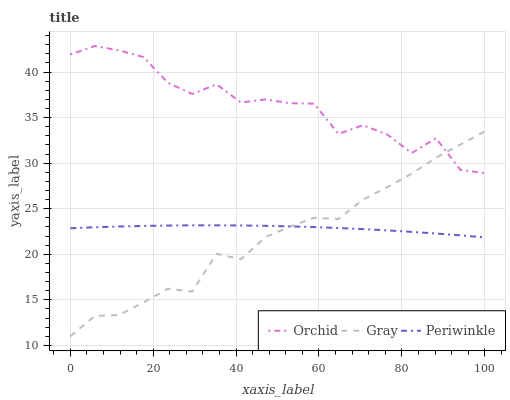Does Gray have the minimum area under the curve?
Answer yes or no. Yes. Does Orchid have the maximum area under the curve?
Answer yes or no. Yes. Does Periwinkle have the minimum area under the curve?
Answer yes or no. No. Does Periwinkle have the maximum area under the curve?
Answer yes or no. No. Is Periwinkle the smoothest?
Answer yes or no. Yes. Is Orchid the roughest?
Answer yes or no. Yes. Is Orchid the smoothest?
Answer yes or no. No. Is Periwinkle the roughest?
Answer yes or no. No. Does Gray have the lowest value?
Answer yes or no. Yes. Does Periwinkle have the lowest value?
Answer yes or no. No. Does Orchid have the highest value?
Answer yes or no. Yes. Does Periwinkle have the highest value?
Answer yes or no. No. Is Periwinkle less than Orchid?
Answer yes or no. Yes. Is Orchid greater than Periwinkle?
Answer yes or no. Yes. Does Gray intersect Orchid?
Answer yes or no. Yes. Is Gray less than Orchid?
Answer yes or no. No. Is Gray greater than Orchid?
Answer yes or no. No. Does Periwinkle intersect Orchid?
Answer yes or no. No. 